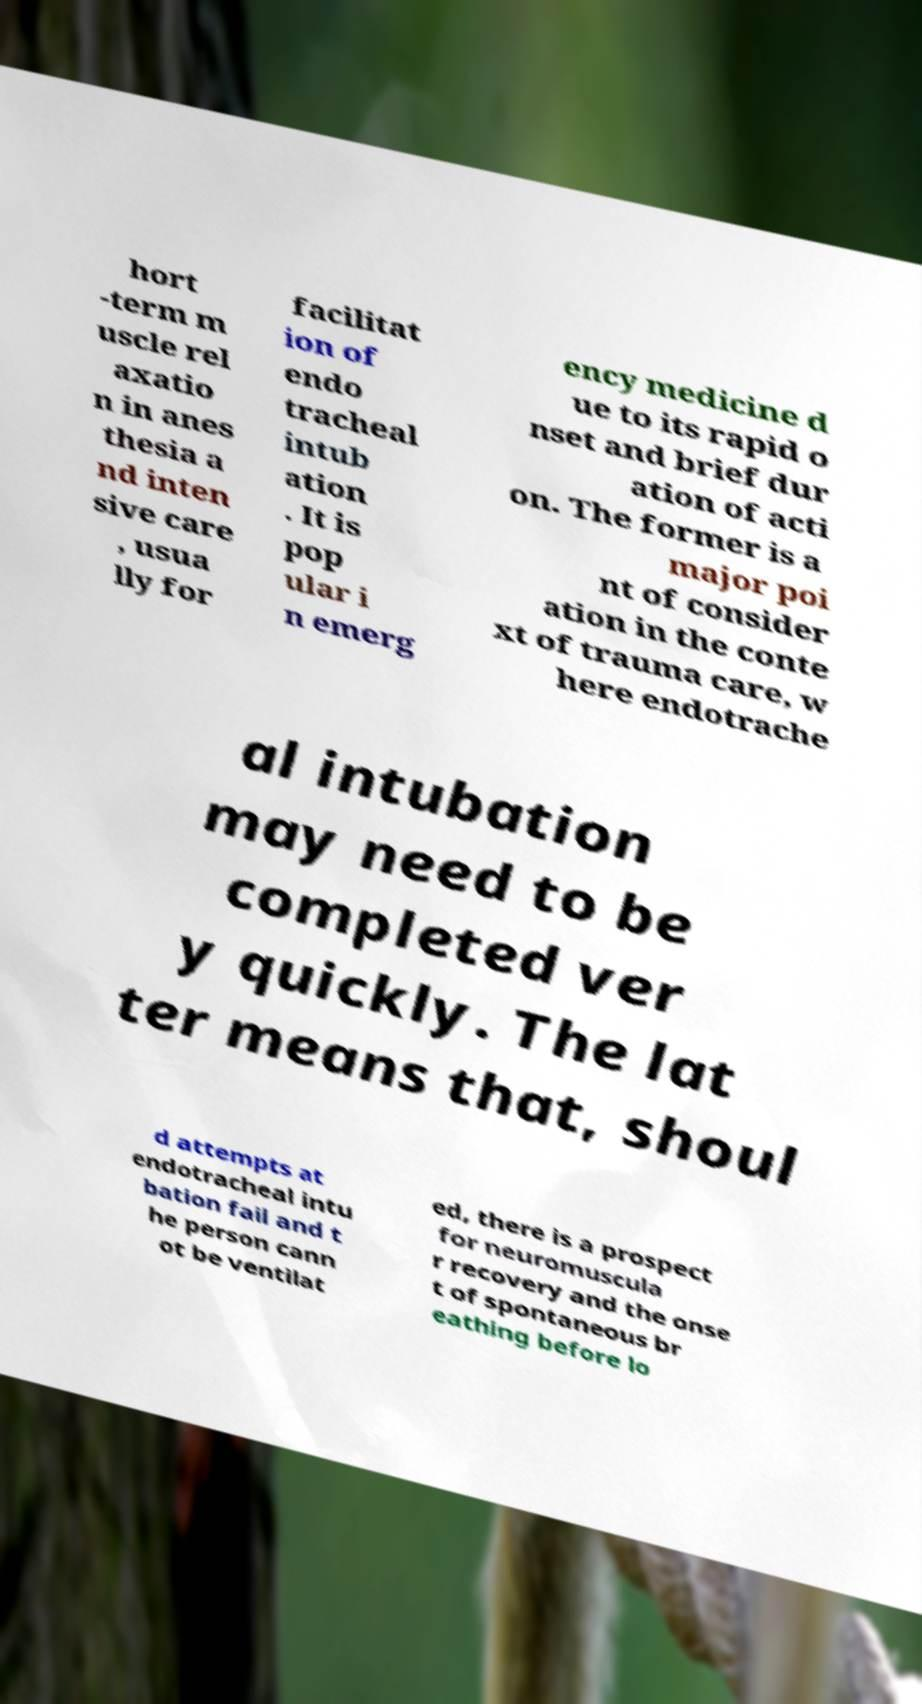Could you assist in decoding the text presented in this image and type it out clearly? hort -term m uscle rel axatio n in anes thesia a nd inten sive care , usua lly for facilitat ion of endo tracheal intub ation . It is pop ular i n emerg ency medicine d ue to its rapid o nset and brief dur ation of acti on. The former is a major poi nt of consider ation in the conte xt of trauma care, w here endotrache al intubation may need to be completed ver y quickly. The lat ter means that, shoul d attempts at endotracheal intu bation fail and t he person cann ot be ventilat ed, there is a prospect for neuromuscula r recovery and the onse t of spontaneous br eathing before lo 